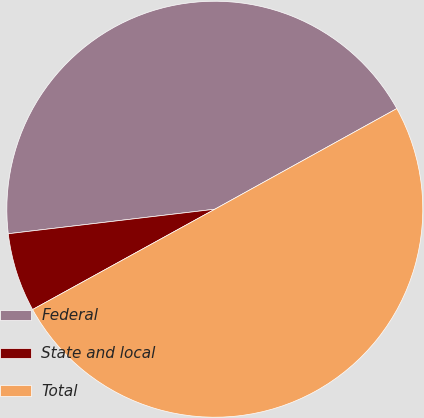Convert chart to OTSL. <chart><loc_0><loc_0><loc_500><loc_500><pie_chart><fcel>Federal<fcel>State and local<fcel>Total<nl><fcel>43.84%<fcel>6.13%<fcel>50.03%<nl></chart> 